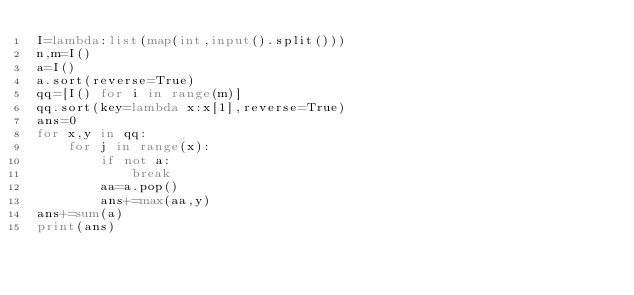Convert code to text. <code><loc_0><loc_0><loc_500><loc_500><_Python_>I=lambda:list(map(int,input().split()))
n,m=I()
a=I()
a.sort(reverse=True)
qq=[I() for i in range(m)]
qq.sort(key=lambda x:x[1],reverse=True)
ans=0
for x,y in qq:
    for j in range(x):
        if not a:
            break
        aa=a.pop()
        ans+=max(aa,y)
ans+=sum(a)
print(ans)
        </code> 